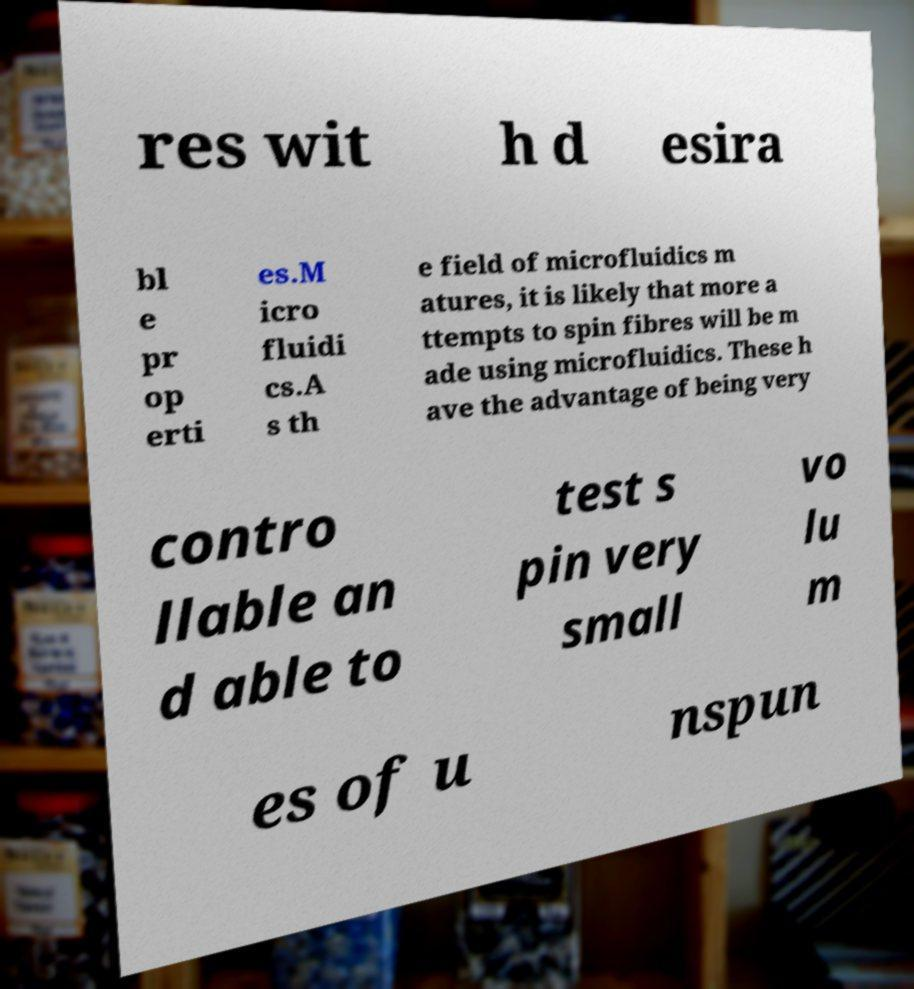There's text embedded in this image that I need extracted. Can you transcribe it verbatim? res wit h d esira bl e pr op erti es.M icro fluidi cs.A s th e field of microfluidics m atures, it is likely that more a ttempts to spin fibres will be m ade using microfluidics. These h ave the advantage of being very contro llable an d able to test s pin very small vo lu m es of u nspun 